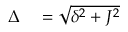<formula> <loc_0><loc_0><loc_500><loc_500>\begin{array} { r l } { \Delta } & = \sqrt { \delta ^ { 2 } + J ^ { 2 } } } \end{array}</formula> 